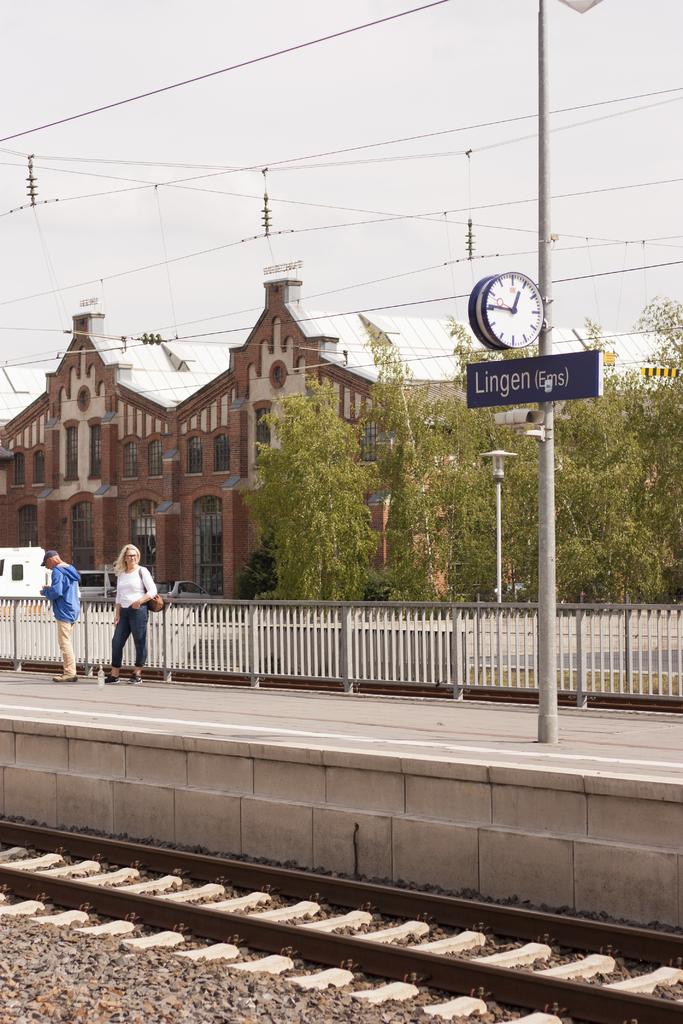What is the street name?
Your response must be concise. Lingen. What time does the clock say?
Offer a terse response. 1:45. 